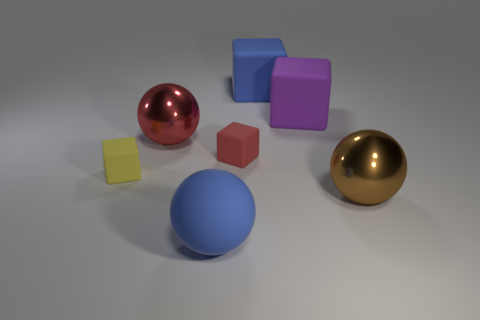Add 2 big purple rubber blocks. How many objects exist? 9 Subtract all cubes. How many objects are left? 3 Add 3 big red things. How many big red things are left? 4 Add 7 tiny yellow rubber things. How many tiny yellow rubber things exist? 8 Subtract 1 purple blocks. How many objects are left? 6 Subtract all large blue things. Subtract all small red rubber things. How many objects are left? 4 